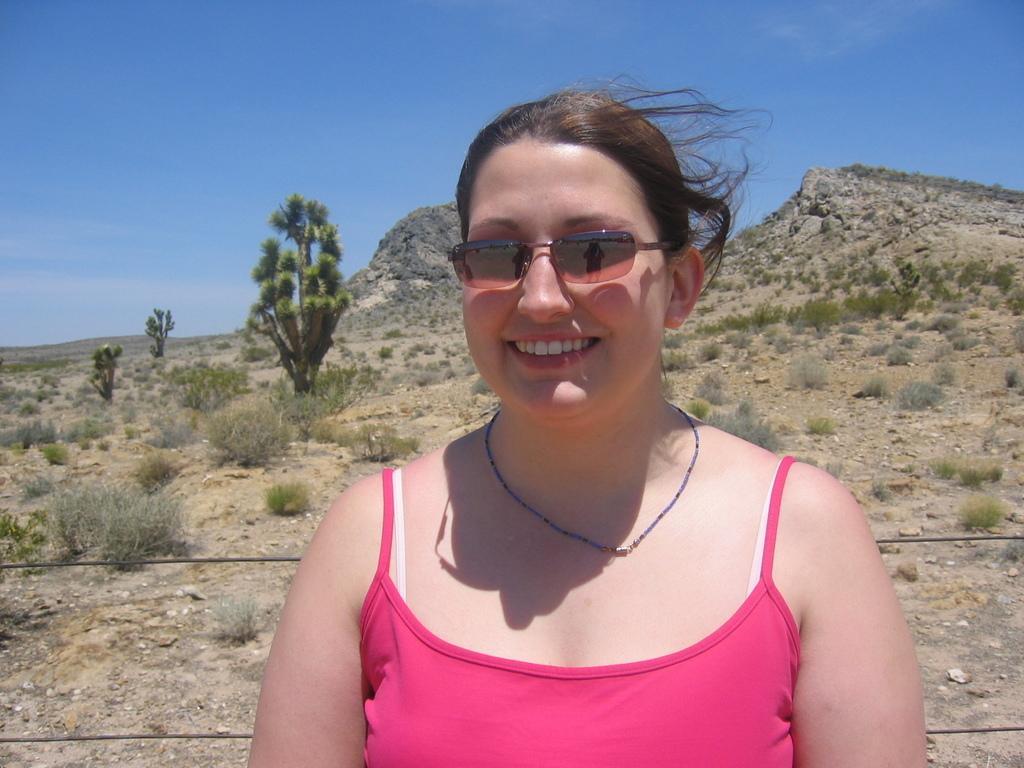Could you give a brief overview of what you see in this image? In the picture I can see a woman and there is a smile on her face. I can see a chain on her neck and goggles on her eyes. It is looking like a metal wire fencing. In the background, I can see the hills and trees. I can see the stones on the ground. There are clouds in the sky. 